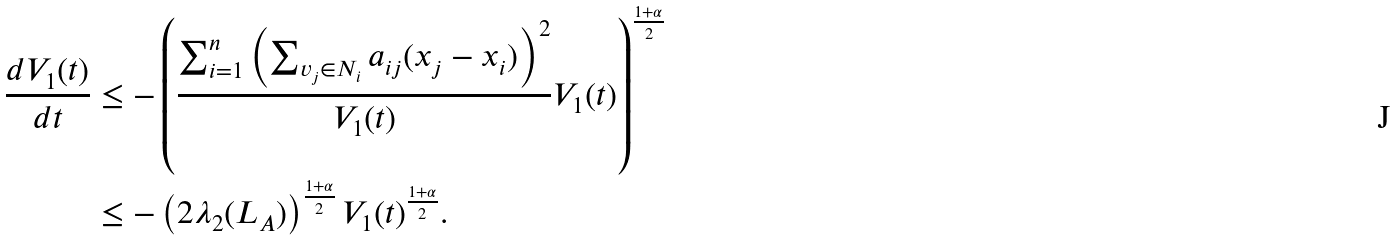Convert formula to latex. <formula><loc_0><loc_0><loc_500><loc_500>\frac { d V _ { 1 } ( t ) } { d t } & \leq - \left ( \frac { \sum _ { i = 1 } ^ { n } \left ( \sum _ { v _ { j } \in N _ { i } } a _ { i j } ( x _ { j } - x _ { i } ) \right ) ^ { 2 } } { V _ { 1 } ( t ) } V _ { 1 } ( t ) \right ) ^ { \frac { 1 + \alpha } { 2 } } \\ & \leq - \left ( 2 \lambda _ { 2 } ( L _ { A } ) \right ) ^ { \frac { 1 + \alpha } { 2 } } V _ { 1 } ( t ) ^ { \frac { 1 + \alpha } { 2 } } .</formula> 